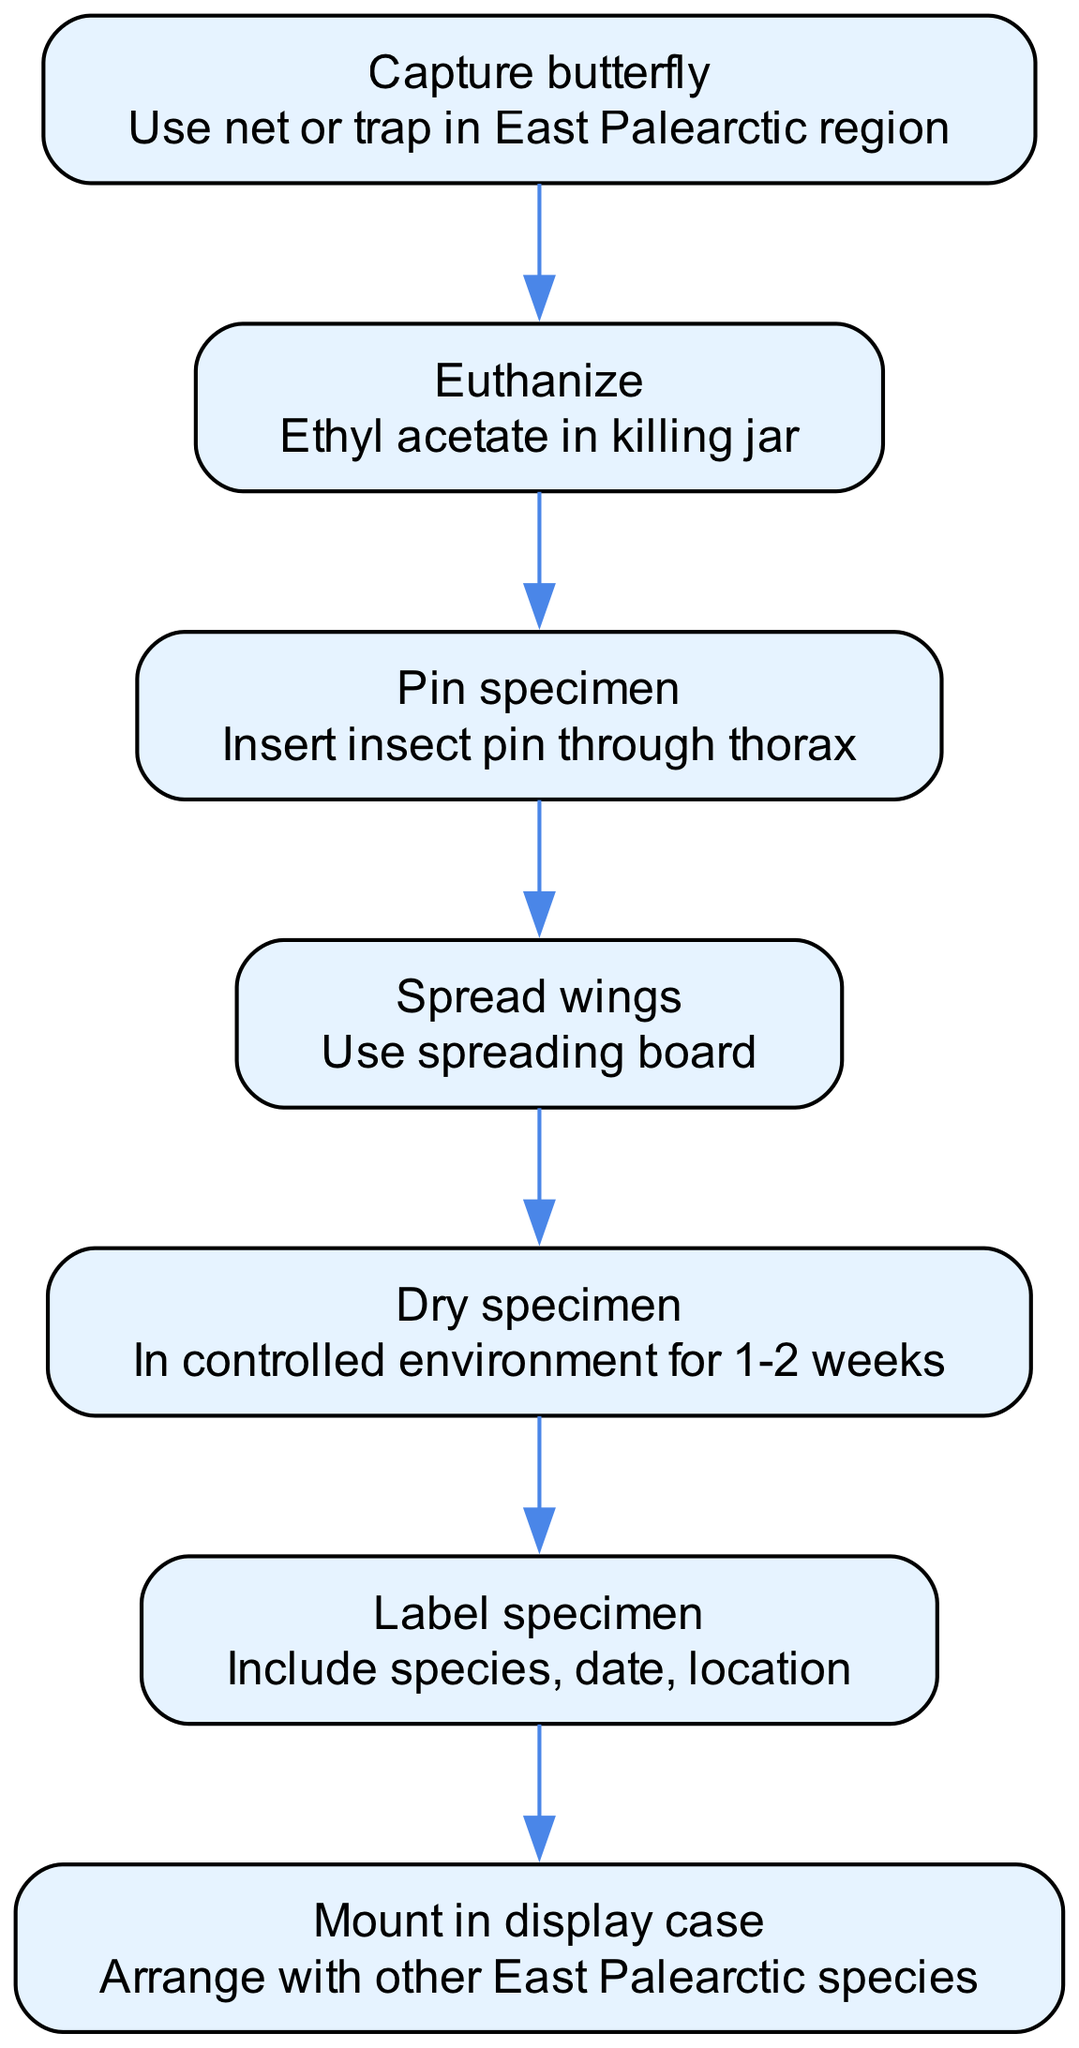What is the first step in the butterfly preservation process? The diagram shows that the first step in the process is "Capture butterfly," as indicated by the starting node.
Answer: Capture butterfly How many nodes are in the diagram? By counting each unique step in the diagram, there are 7 nodes listed in total.
Answer: 7 What follows after "Euthanize"? According to the flow of the diagram, "Pin specimen" is the immediate next step following "Euthanize."
Answer: Pin specimen What is involved in drying the specimen? The details for drying the specimen include "In controlled environment for 1-2 weeks," which is explicitly mentioned in the relevant node.
Answer: In controlled environment for 1-2 weeks Which step comes just before labeling the specimen? The diagram indicates that the step just before labeling the specimen is "Dry specimen," which is the preceding node in the flow.
Answer: Dry specimen What type of board is used during the wing spreading process? The diagram specifies that a "spreading board" is used for the wings during the corresponding step.
Answer: Spreading board How many edges connect the nodes in the diagram? By reviewing the connections in the diagram, there are 6 edges linking the nodes together throughout the process.
Answer: 6 After pinning the specimen, which action is next? The flow of the diagram shows that the next action after pinning the specimen is to "Spread wings."
Answer: Spread wings What additional information should be included on the label? The diagram notes that the label should include "species, date, location," indicating the necessary information to accompany the specimen.
Answer: Species, date, location 